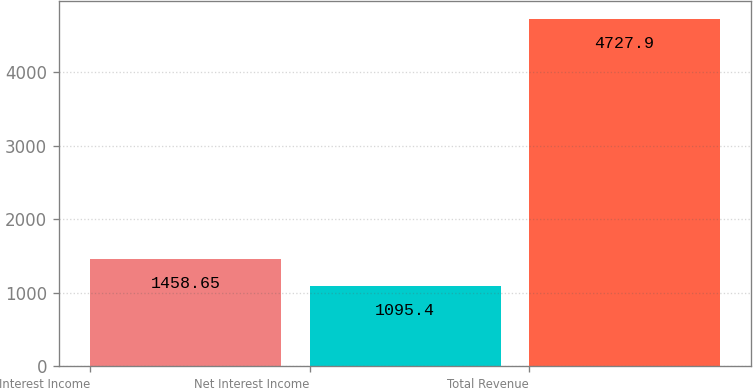Convert chart to OTSL. <chart><loc_0><loc_0><loc_500><loc_500><bar_chart><fcel>Interest Income<fcel>Net Interest Income<fcel>Total Revenue<nl><fcel>1458.65<fcel>1095.4<fcel>4727.9<nl></chart> 